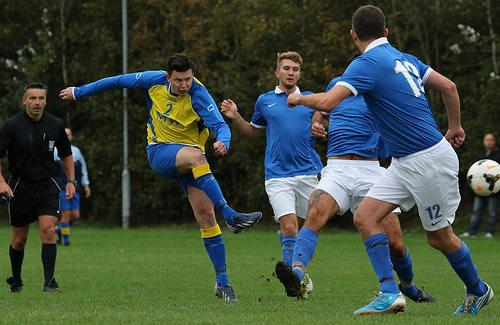<image>
Can you confirm if the referee is behind the player? Yes. From this viewpoint, the referee is positioned behind the player, with the player partially or fully occluding the referee. 